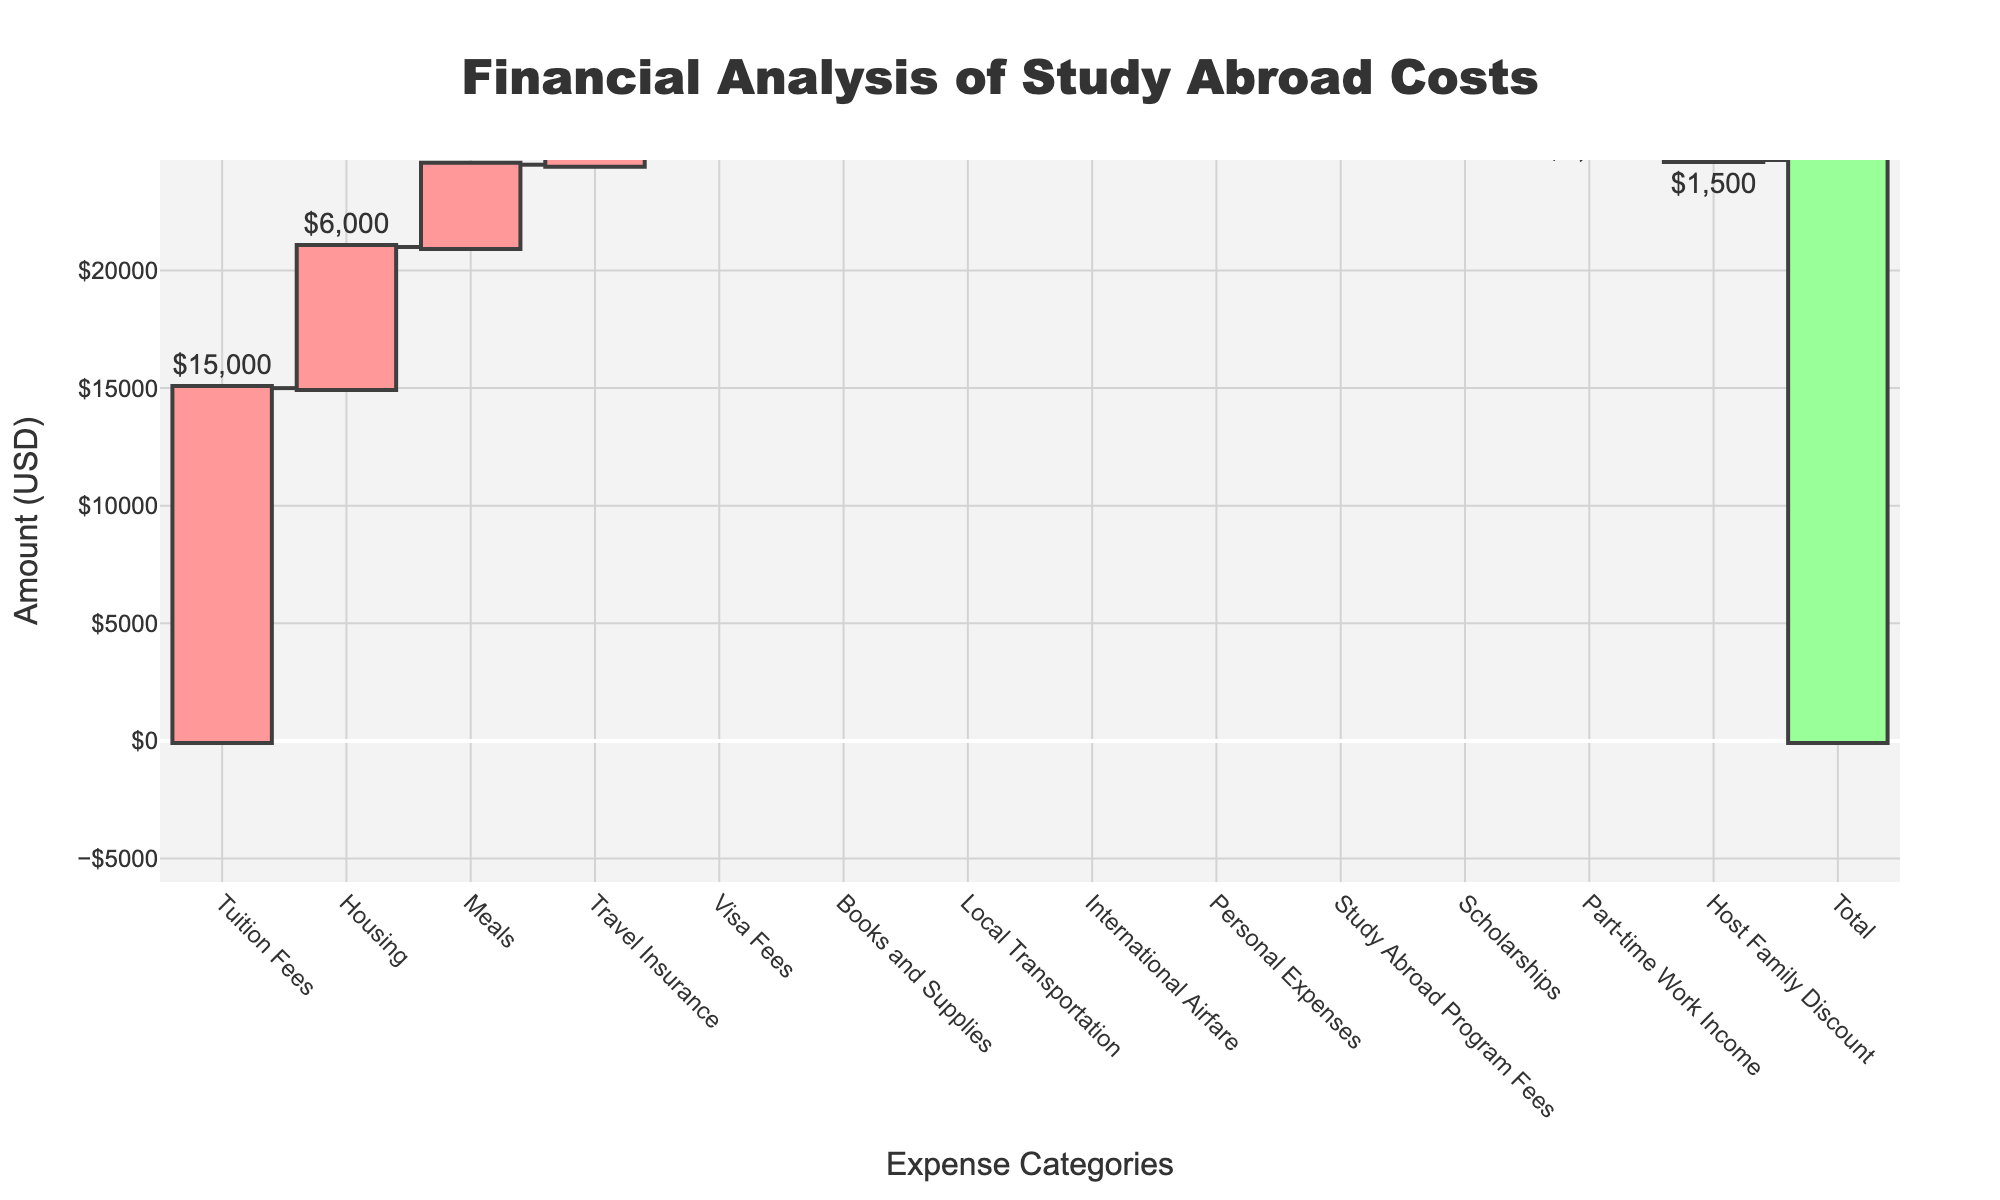What is the title of the chart? The title is at the top of the chart and reads "Financial Analysis of Study Abroad Costs".
Answer: Financial Analysis of Study Abroad Costs What is the total amount shown at the end of the waterfall chart? The total amount is displayed as the last bar in the chart, which is labeled "Total" and shows $23,700.
Answer: $23,700 What are the three largest expense categories? The three largest expense categories can be identified by the tallest bars representing positive amounts: "Tuition Fees" ($15,000), "Housing" ($6,000), and "Meals" ($3,500).
Answer: Tuition Fees, Housing, Meals What are the categories that provide income or savings, thereby decreasing the total expenses? The categories that lower the total expenses have negative values: "Scholarships" (-$5,000), "Part-time Work Income" (-$2,000), and "Host Family Discount" (-$1,500).
Answer: Scholarships, Part-time Work Income, Host Family Discount How much does International Airfare add to the total expenses? The amount for International Airfare is identified by its label on the bar representing this category, which is $1,200.
Answer: $1,200 What is the difference in cost between Housing and Meals? Subtract the amount for Meals from Housing: $6,000 - $3,500 = $2,500.
Answer: $2,500 Which expense category has the smallest value, and what is that value? The category with the smallest positive value is identified by the shortest bar: "Visa Fees" with $300.
Answer: Visa Fees, $300 How do the scholarships affect the overall total, compared to the starting balance? Scholarships decrease the total expenses and are represented as a negative value, thereby reducing the final total by $5,000 from the starting balance.
Answer: They reduce by $5,000 What is the net effect of Part-time Work Income and Host Family Discount on the total expenses? Add the values of Part-time Work Income (-$2,000) and Host Family Discount (-$1,500): -$2,000 + (-$1,500) = -$3,500.
Answer: -$3,500 If you remove the study abroad program fees from the total expenses, what would be the new total? Subtract the Study Abroad Program Fees from the total: $23,700 - $2,500 = $21,200.
Answer: $21,200 